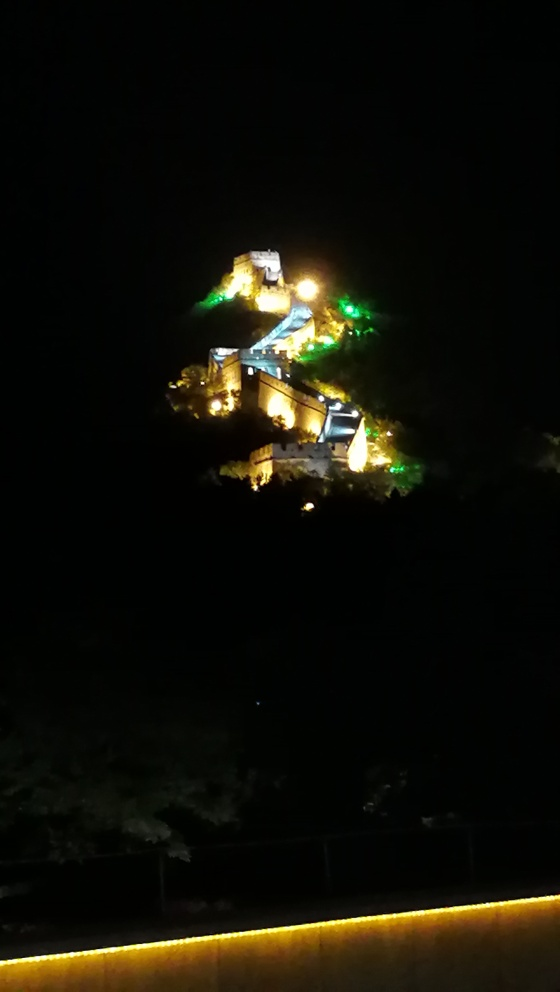What can you infer about the location and setting of the place in this image? Given that the image is taken at night, with the structure dramatically lit against the darkness, it's likely that this is a location that holds significance, perhaps culturally or historically. The lighting suggests that it is a place intended to be seen and admired even at night, which often is the case in touristic and historically important locations. The dense darkness surrounding the structure may imply a remote setting or that the surrounding area is less developed and free from urban light pollution, highlighting the structure's prominence. What kind of events or activities might take place at this location? Given its striking illumination and prominence, the location could host a variety of evening events such as light shows, guided night tours, or cultural performances. Additionally, it might be the centrepiece for festivals or celebrations, particularly those that are historic in nature. As a daytime venue, it would likely attract sightseers, historians, and enthusiasts interested in its architecture and the stories behind it. 